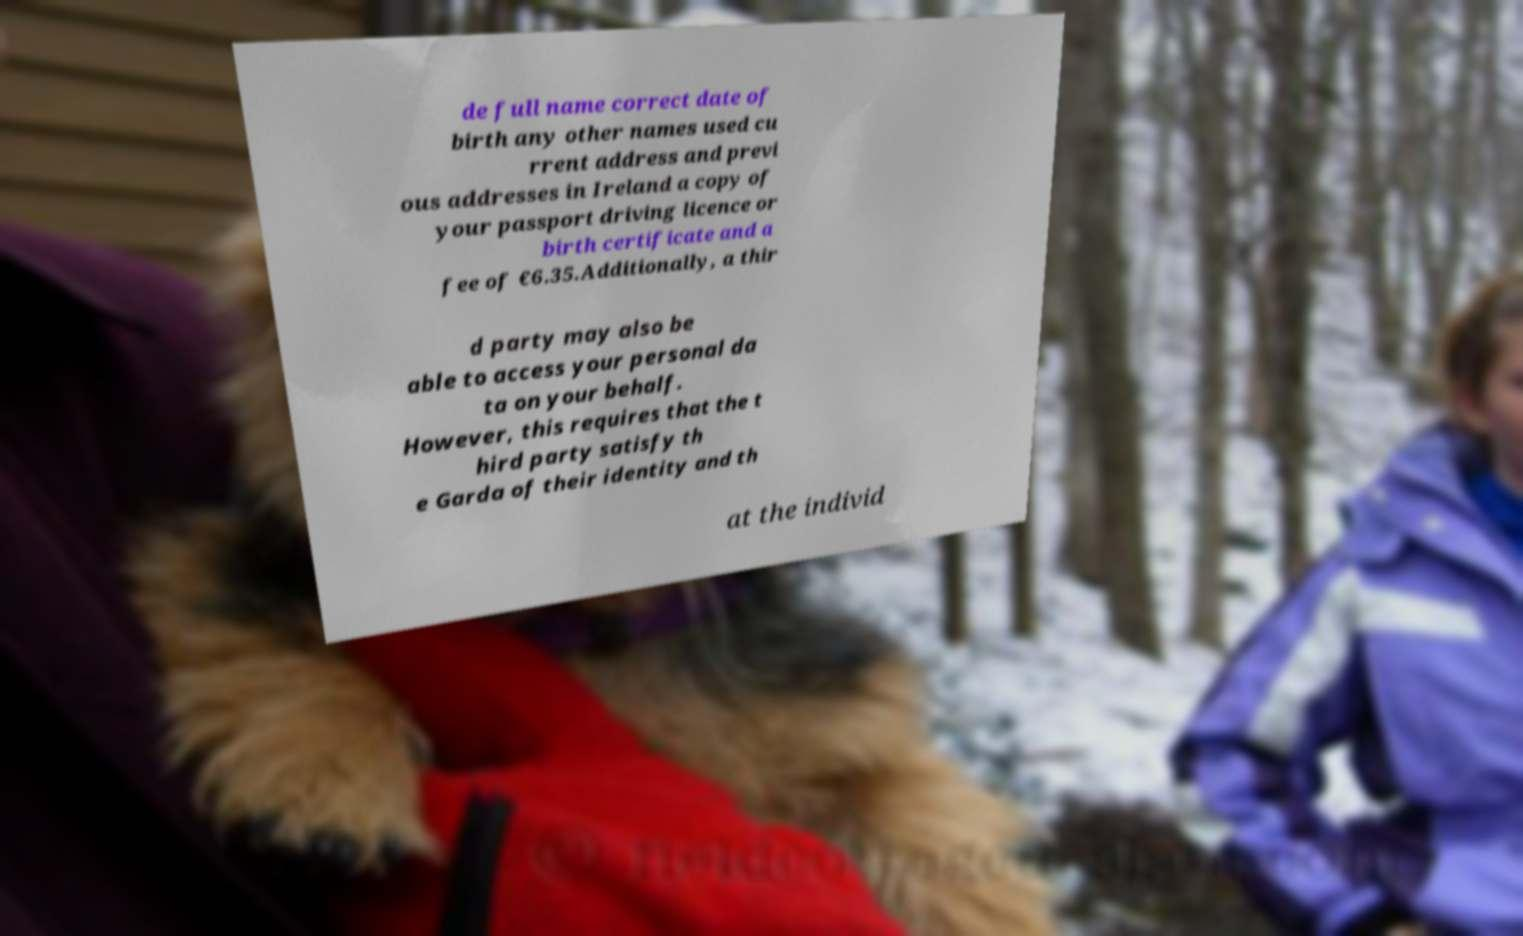Can you accurately transcribe the text from the provided image for me? de full name correct date of birth any other names used cu rrent address and previ ous addresses in Ireland a copy of your passport driving licence or birth certificate and a fee of €6.35.Additionally, a thir d party may also be able to access your personal da ta on your behalf. However, this requires that the t hird party satisfy th e Garda of their identity and th at the individ 